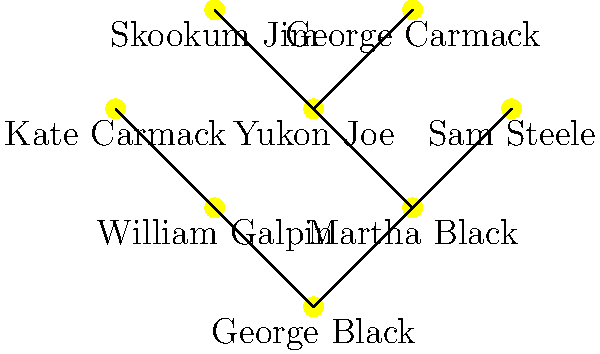In the family tree diagram of prominent Yukon historical figures, which individual is directly connected to both George Black and Yukon Joe? To answer this question, we need to analyze the connections in the family tree diagram:

1. First, identify George Black in the diagram. He is at the bottom center of the tree.

2. Look at the connections stemming from George Black. He is directly connected to two individuals: Martha Black and William Galpin.

3. Next, locate Yukon Joe in the diagram. He is in the upper left branch of the tree.

4. Trace back from Yukon Joe to see who he is directly connected to. Yukon Joe is directly connected to Martha Black.

5. Compare the connections:
   - George Black is connected to Martha Black and William Galpin
   - Yukon Joe is connected to Martha Black

6. The only person who is directly connected to both George Black and Yukon Joe is Martha Black.

Therefore, Martha Black is the individual directly connected to both George Black and Yukon Joe in this family tree diagram.
Answer: Martha Black 